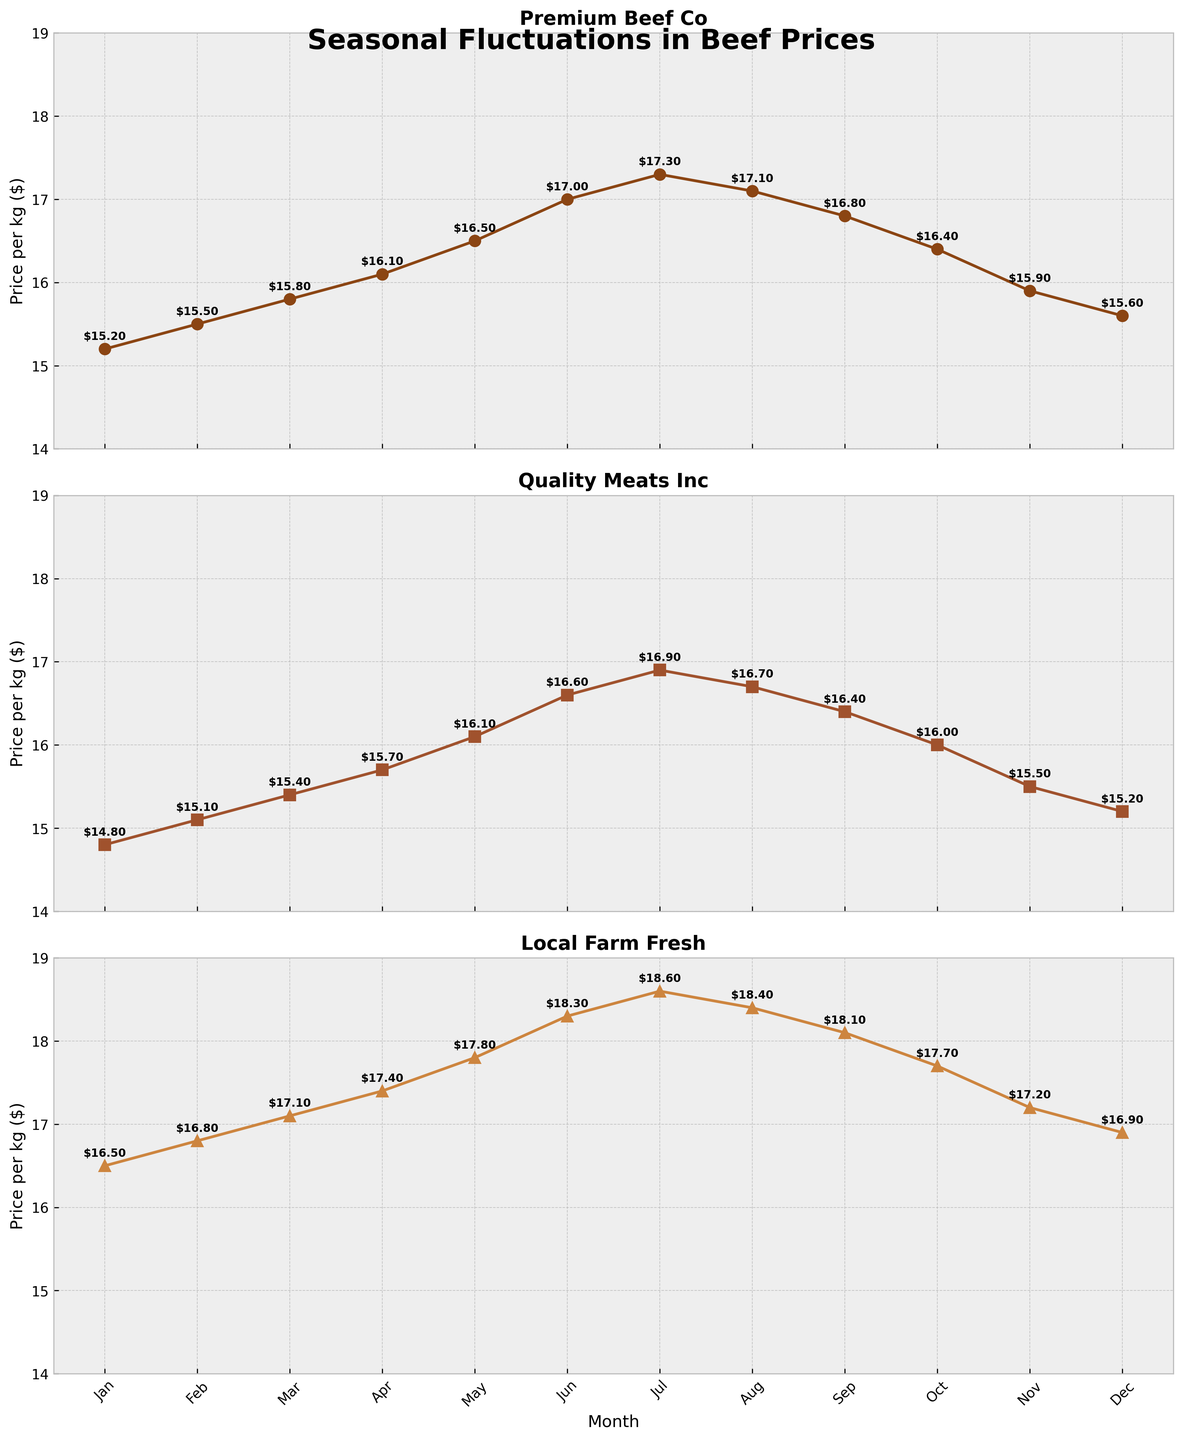What's the average price per kg for "Premium Beef Co" over the year? To compute the average price for "Premium Beef Co," sum up the monthly prices and then divide by 12 (number of months). The sum is 186.2, so 186.2 / 12 = 15.52
Answer: 15.52 Which supplier has the highest average price per kg? Calculate the average price for each supplier by summing their monthly prices and dividing by 12. Premium Beef Co: 15.52, Quality Meats Inc: 15.87, Local Farm Fresh: 17.50. Local Farm Fresh has the highest average.
Answer: Local Farm Fresh During which month does "Quality Meats Inc" have the lowest price per kg? Locate the lowest point on the "Quality Meats Inc" subplot and identify the month. The lowest price is in January and December, both at $14.80 and $15.20 respectively. January has the lowest price.
Answer: January How does the price trend of "Premium Beef Co" compare to "Quality Meats Inc" over the months? Observe both subplots to compare trends. Both prices increase from January to July, then decrease from August to December. Quality Meats Inc's prices are generally slightly lower.
Answer: Similar trends; slight price differences What is the price difference between "Premium Beef Co" and "Local Farm Fresh" in June? Find the prices for both suppliers in June: Premium Beef Co is $17.00 and Local Farm Fresh is $18.30. The difference is $18.30 - $17.00 = $1.30.
Answer: $1.30 In which month is the price per kg highest for any supplier? Look for the highest point in all subplots. "Local Farm Fresh" in July has the highest price at $18.60.
Answer: July Compare the price variability among the three suppliers. Which one shows the most significant fluctuations? Compare the range and changes in prices for each supplier's subplot. "Local Farm Fresh" shows the most significant variability, ranging from $16.50 to $18.60.
Answer: Local Farm Fresh What is the price range for "Quality Meats Inc" over the year? Identify the highest and lowest prices for "Quality Meats Inc." The highest price is $16.90 in July, and the lowest is $14.80 in January. The range is $16.90 - $14.80 = $2.10.
Answer: $2.10 How do the December prices of all suppliers compare? Extract the December prices: Premium Beef Co is $15.60, Quality Meats Inc is $15.20, Local Farm Fresh is $16.90. Compare these values.
Answer: Premium Beef Co: $15.60, Quality Meats Inc: $15.20, Local Farm Fresh: $16.90 During which months do "Local Farm Fresh" have prices below $17.00? Check the "Local Farm Fresh" subplot for months where prices are below $17.00. The months are January, February, November, and December.
Answer: January, February, November, December 